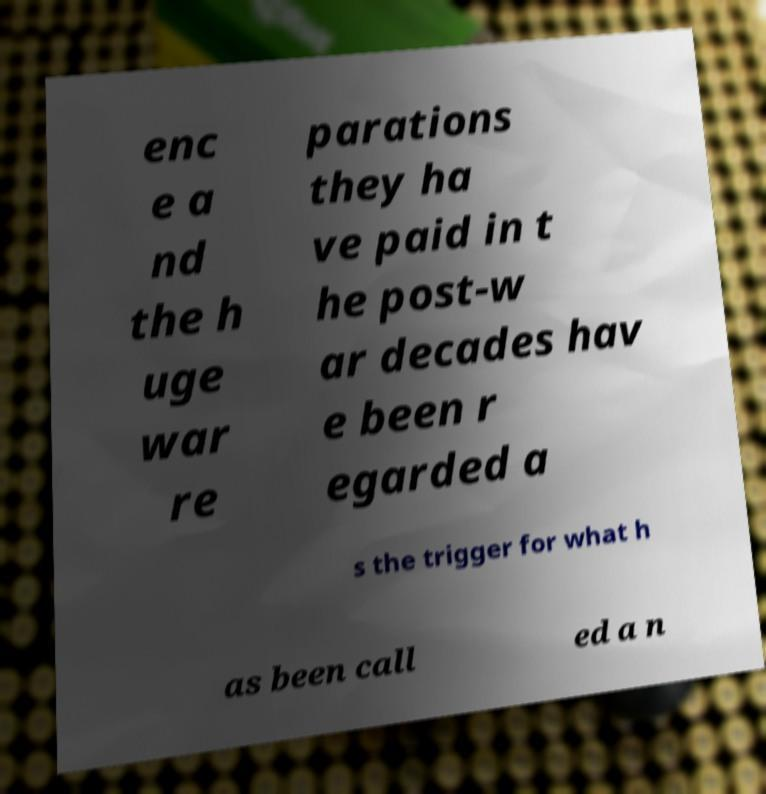Can you accurately transcribe the text from the provided image for me? enc e a nd the h uge war re parations they ha ve paid in t he post-w ar decades hav e been r egarded a s the trigger for what h as been call ed a n 